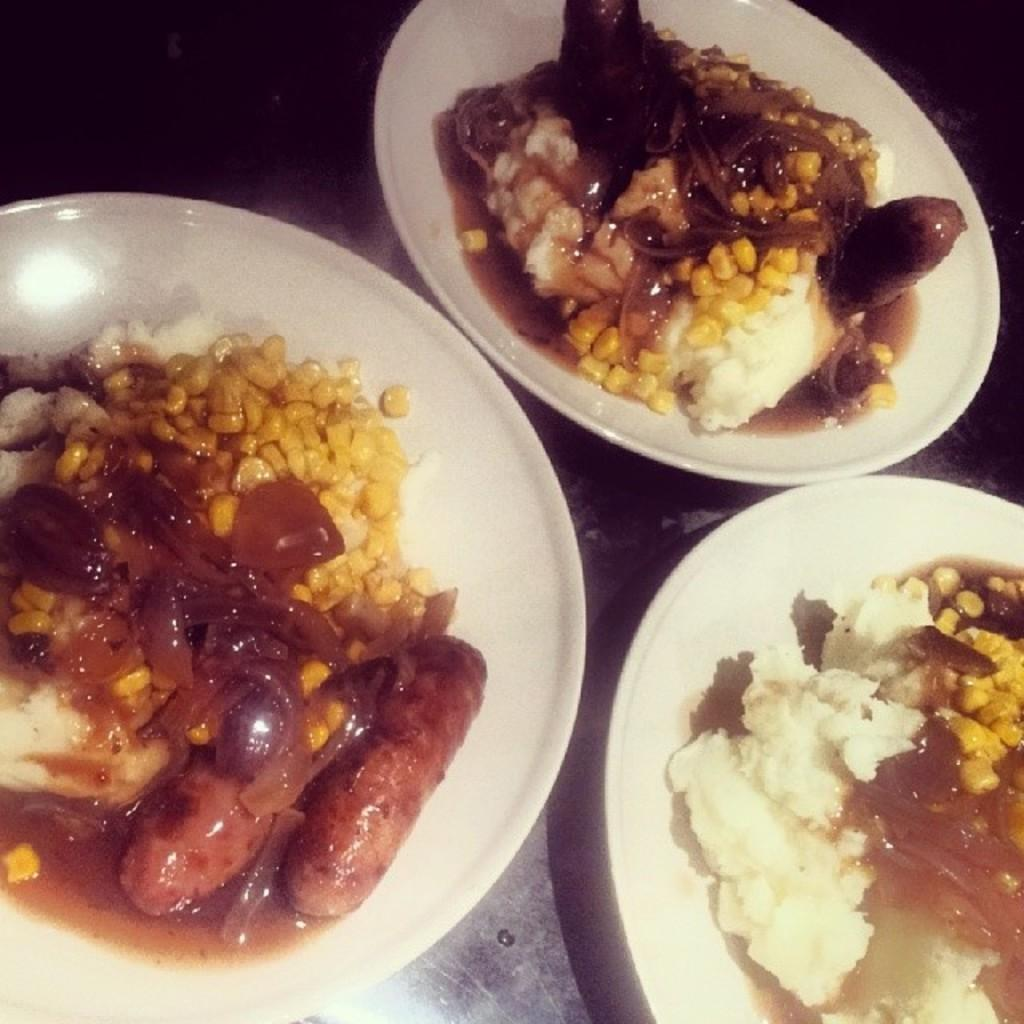How many plates are visible in the image? There are three plates in the image. What is on each of the plates? Each plate contains food. Where are the plates located? The plates are placed on a table. How does the tongue help with the food on the plates in the image? There is no tongue present in the image, and therefore no such interaction can be observed. 